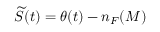<formula> <loc_0><loc_0><loc_500><loc_500>\widetilde { S } ( t ) = \theta ( t ) - n _ { F } ( M )</formula> 